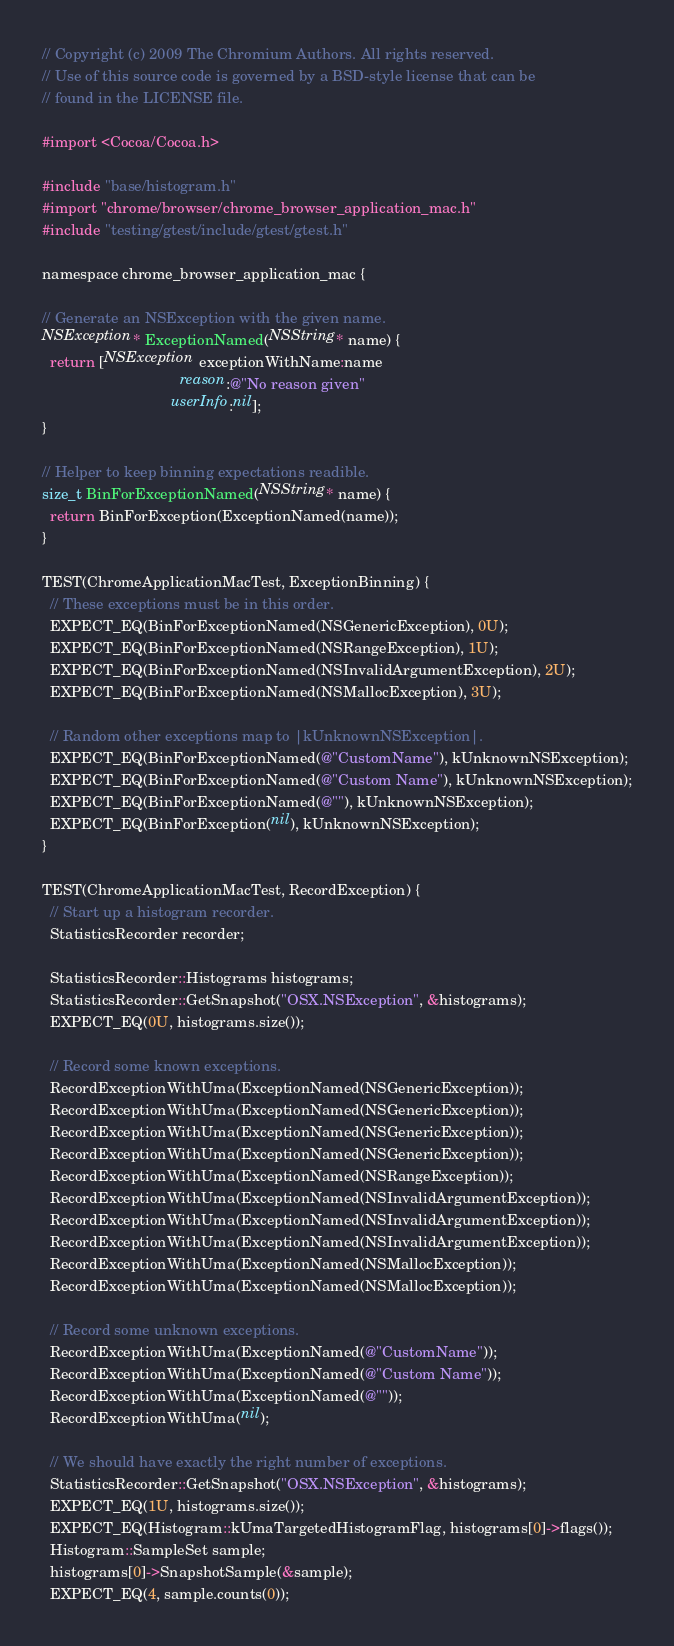<code> <loc_0><loc_0><loc_500><loc_500><_ObjectiveC_>// Copyright (c) 2009 The Chromium Authors. All rights reserved.
// Use of this source code is governed by a BSD-style license that can be
// found in the LICENSE file.

#import <Cocoa/Cocoa.h>

#include "base/histogram.h"
#import "chrome/browser/chrome_browser_application_mac.h"
#include "testing/gtest/include/gtest/gtest.h"

namespace chrome_browser_application_mac {

// Generate an NSException with the given name.
NSException* ExceptionNamed(NSString* name) {
  return [NSException exceptionWithName:name
                                 reason:@"No reason given"
                               userInfo:nil];
}

// Helper to keep binning expectations readible.
size_t BinForExceptionNamed(NSString* name) {
  return BinForException(ExceptionNamed(name));
}

TEST(ChromeApplicationMacTest, ExceptionBinning) {
  // These exceptions must be in this order.
  EXPECT_EQ(BinForExceptionNamed(NSGenericException), 0U);
  EXPECT_EQ(BinForExceptionNamed(NSRangeException), 1U);
  EXPECT_EQ(BinForExceptionNamed(NSInvalidArgumentException), 2U);
  EXPECT_EQ(BinForExceptionNamed(NSMallocException), 3U);

  // Random other exceptions map to |kUnknownNSException|.
  EXPECT_EQ(BinForExceptionNamed(@"CustomName"), kUnknownNSException);
  EXPECT_EQ(BinForExceptionNamed(@"Custom Name"), kUnknownNSException);
  EXPECT_EQ(BinForExceptionNamed(@""), kUnknownNSException);
  EXPECT_EQ(BinForException(nil), kUnknownNSException);
}

TEST(ChromeApplicationMacTest, RecordException) {
  // Start up a histogram recorder.
  StatisticsRecorder recorder;

  StatisticsRecorder::Histograms histograms;
  StatisticsRecorder::GetSnapshot("OSX.NSException", &histograms);
  EXPECT_EQ(0U, histograms.size());

  // Record some known exceptions.
  RecordExceptionWithUma(ExceptionNamed(NSGenericException));
  RecordExceptionWithUma(ExceptionNamed(NSGenericException));
  RecordExceptionWithUma(ExceptionNamed(NSGenericException));
  RecordExceptionWithUma(ExceptionNamed(NSGenericException));
  RecordExceptionWithUma(ExceptionNamed(NSRangeException));
  RecordExceptionWithUma(ExceptionNamed(NSInvalidArgumentException));
  RecordExceptionWithUma(ExceptionNamed(NSInvalidArgumentException));
  RecordExceptionWithUma(ExceptionNamed(NSInvalidArgumentException));
  RecordExceptionWithUma(ExceptionNamed(NSMallocException));
  RecordExceptionWithUma(ExceptionNamed(NSMallocException));

  // Record some unknown exceptions.
  RecordExceptionWithUma(ExceptionNamed(@"CustomName"));
  RecordExceptionWithUma(ExceptionNamed(@"Custom Name"));
  RecordExceptionWithUma(ExceptionNamed(@""));
  RecordExceptionWithUma(nil);

  // We should have exactly the right number of exceptions.
  StatisticsRecorder::GetSnapshot("OSX.NSException", &histograms);
  EXPECT_EQ(1U, histograms.size());
  EXPECT_EQ(Histogram::kUmaTargetedHistogramFlag, histograms[0]->flags());
  Histogram::SampleSet sample;
  histograms[0]->SnapshotSample(&sample);
  EXPECT_EQ(4, sample.counts(0));</code> 